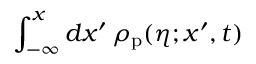Convert formula to latex. <formula><loc_0><loc_0><loc_500><loc_500>\int _ { - \infty } ^ { x } d x ^ { \prime } \, \rho _ { p } ( \eta ; x ^ { \prime } , t )</formula> 